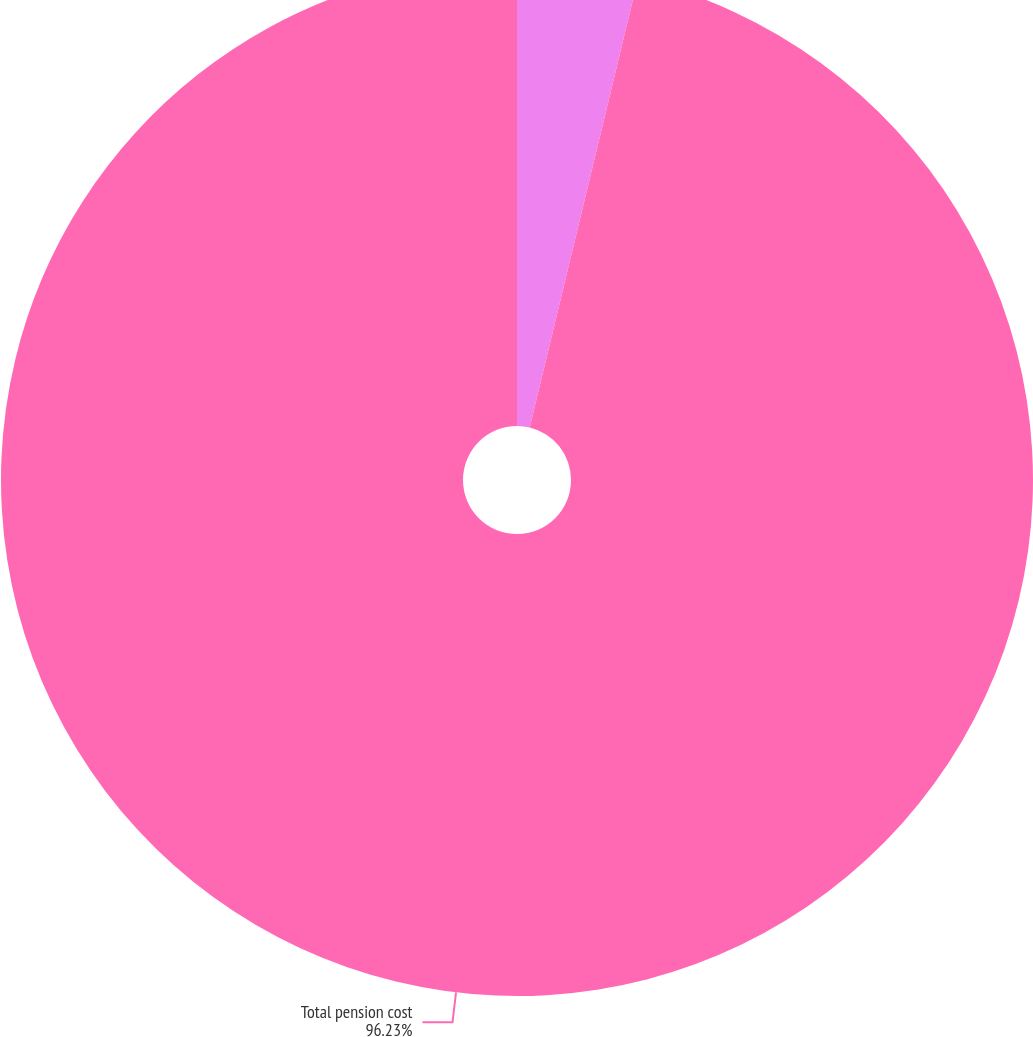Convert chart. <chart><loc_0><loc_0><loc_500><loc_500><pie_chart><fcel>Amortization of net loss<fcel>Total pension cost<nl><fcel>3.77%<fcel>96.23%<nl></chart> 